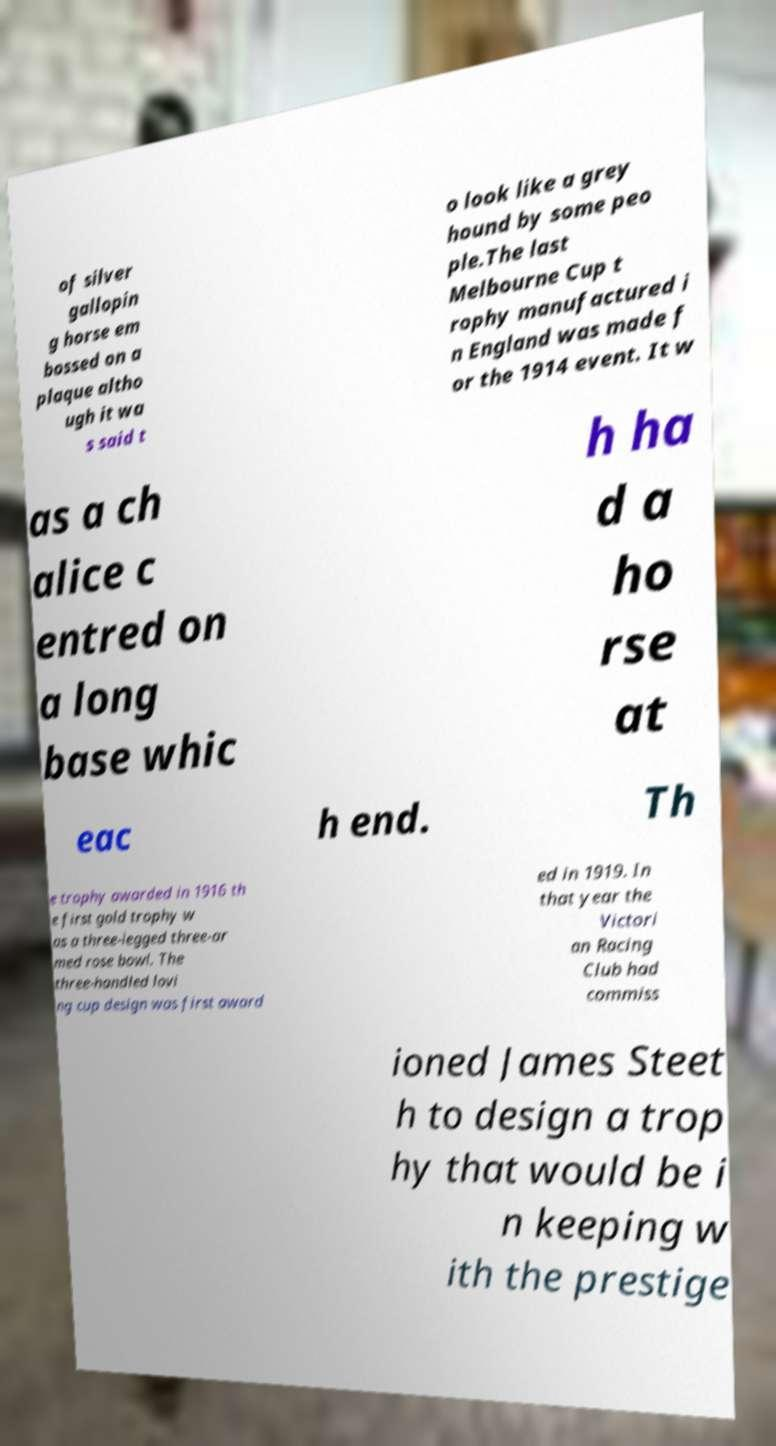There's text embedded in this image that I need extracted. Can you transcribe it verbatim? of silver gallopin g horse em bossed on a plaque altho ugh it wa s said t o look like a grey hound by some peo ple.The last Melbourne Cup t rophy manufactured i n England was made f or the 1914 event. It w as a ch alice c entred on a long base whic h ha d a ho rse at eac h end. Th e trophy awarded in 1916 th e first gold trophy w as a three-legged three-ar med rose bowl. The three-handled lovi ng cup design was first award ed in 1919. In that year the Victori an Racing Club had commiss ioned James Steet h to design a trop hy that would be i n keeping w ith the prestige 